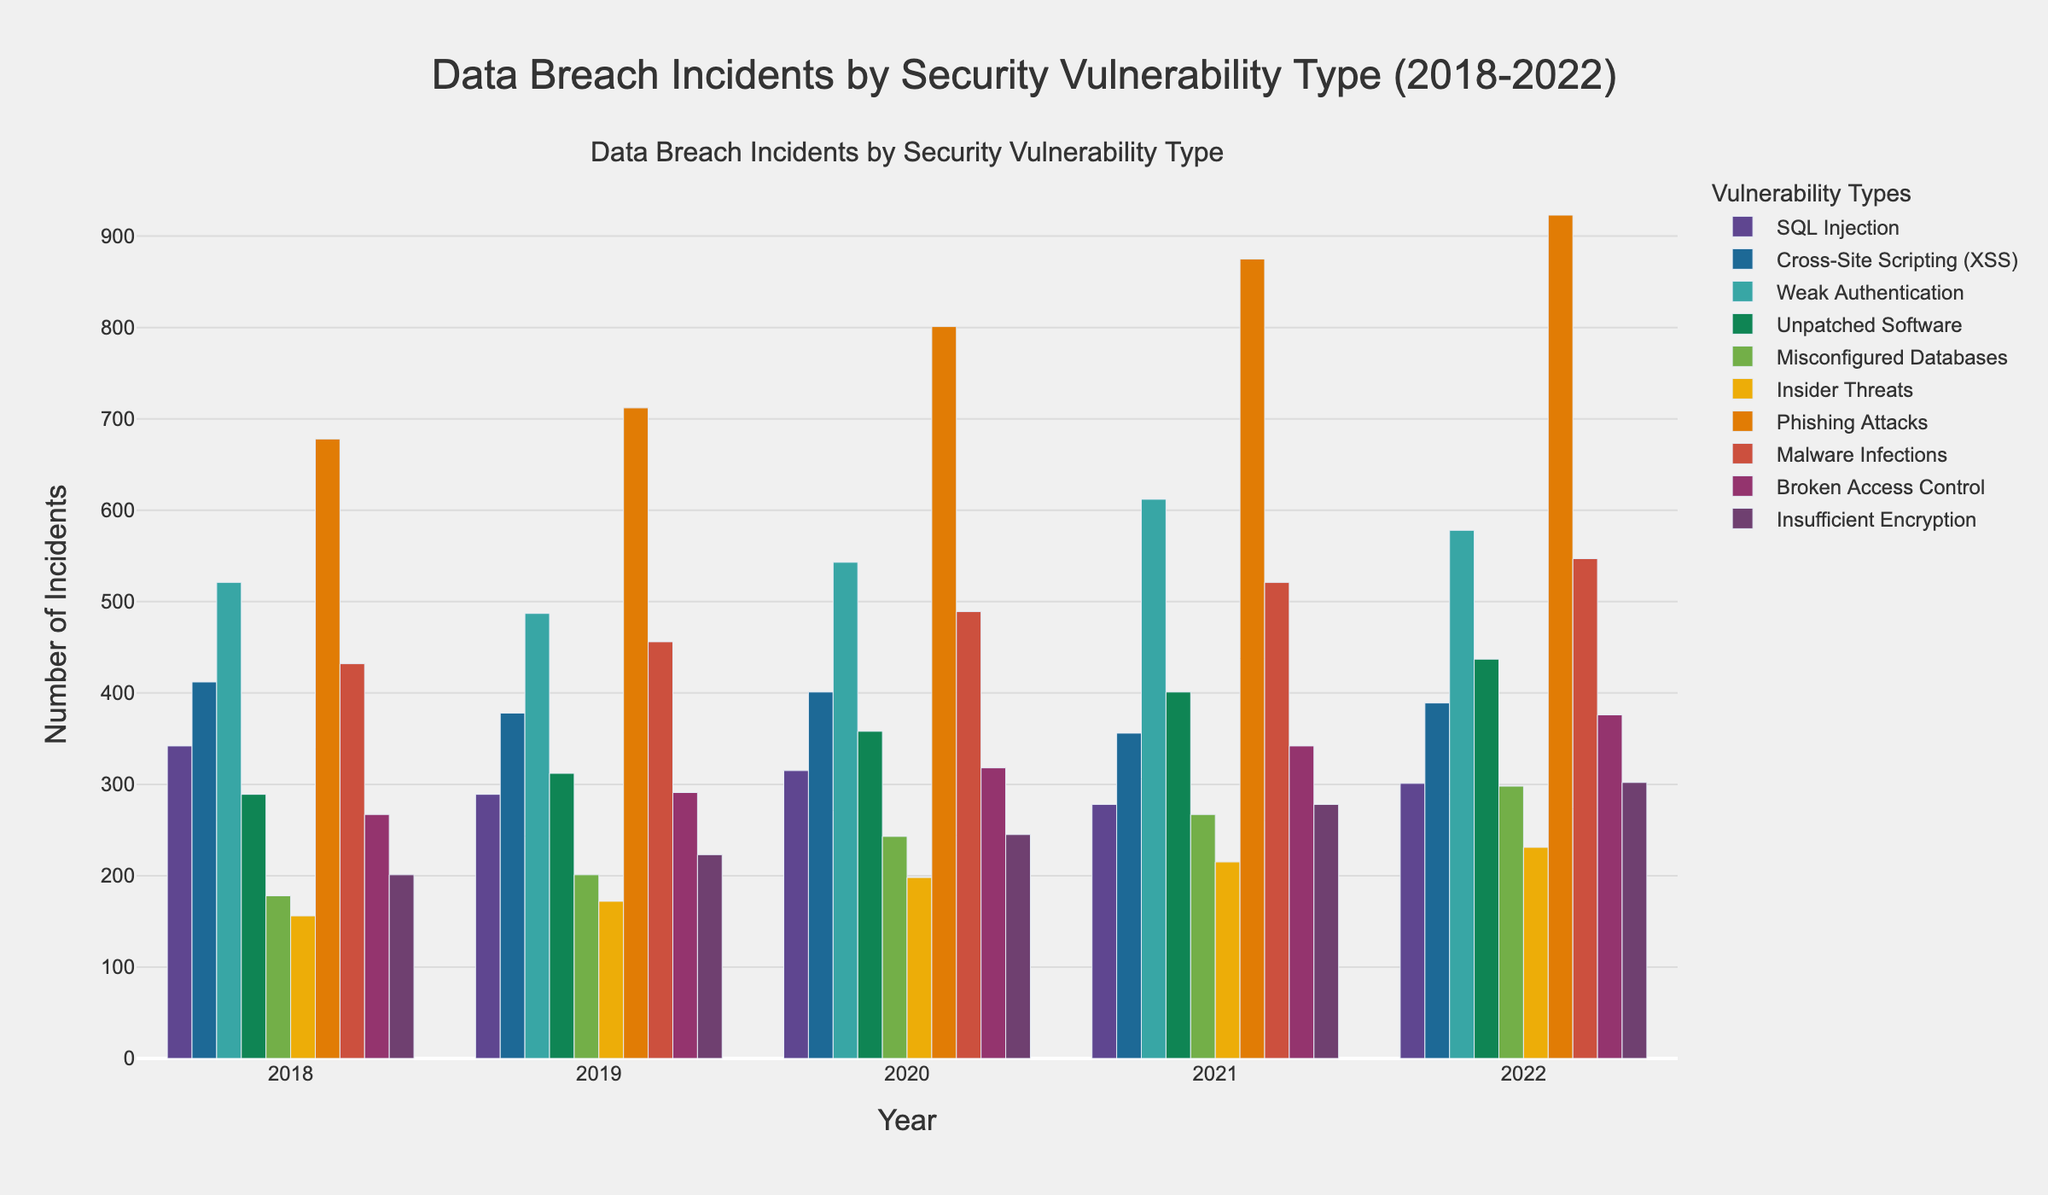Which year had the highest number of data breach incidents caused by Phishing Attacks? The highest bar for Phishing Attacks is in 2022.
Answer: 2022 In 2021, which security vulnerability type had the second-highest number of incidents? For 2021, Phishing Attacks had the highest incidents. The second highest bar is for Weak Authentication.
Answer: Weak Authentication How did the number of incidents due to Unpatched Software change from 2020 to 2022? In 2020, there were 358 incidents, and in 2022, there were 437 incidents. The difference is 437 - 358.
Answer: Increased by 79 Which security vulnerability type saw the largest decrease in incidents from 2019 to 2020? By inspecting the bars from 2019 to 2020, SQL Injection shows a decrease from 289 to 315. The largest decrease is found here.
Answer: SQL Injection What is the average number of incidents for Cross-Site Scripting (XSS) over the 5 years? Sum of incidents: 412 + 378 + 401 + 356 + 389 = 1936. The average is 1936/5.
Answer: 387.2 Which security vulnerability type had fewer incidents in 2022 compared to 2018? Comparing the bars for 2022 and 2018, SQL Injection shows a decrease from 342 to 301.
Answer: SQL Injection What is the combined total number of incidents for Weak Authentication and Insider Threats in 2021? Weak Authentication in 2021 had 612 incidents. Insider Threats had 215. The total is 612 + 215.
Answer: 827 By how much did the number of incidents for Misconfigured Databases increase from 2018 to 2022? In 2018, there were 178 incidents, and in 2022, there were 298 incidents. The difference is 298 - 178.
Answer: Increased by 120 Which year had the lowest number of incidents for Broken Access Control? The lowest bar for Broken Access Control is in 2018.
Answer: 2018 Are the incidents due to Malware Infections in 2019 greater than those due to SQL Injection in the same year? In 2019, Malware Infections had 456 incidents. SQL Injection had 289. Since 456 is greater than 289, yes.
Answer: Yes 